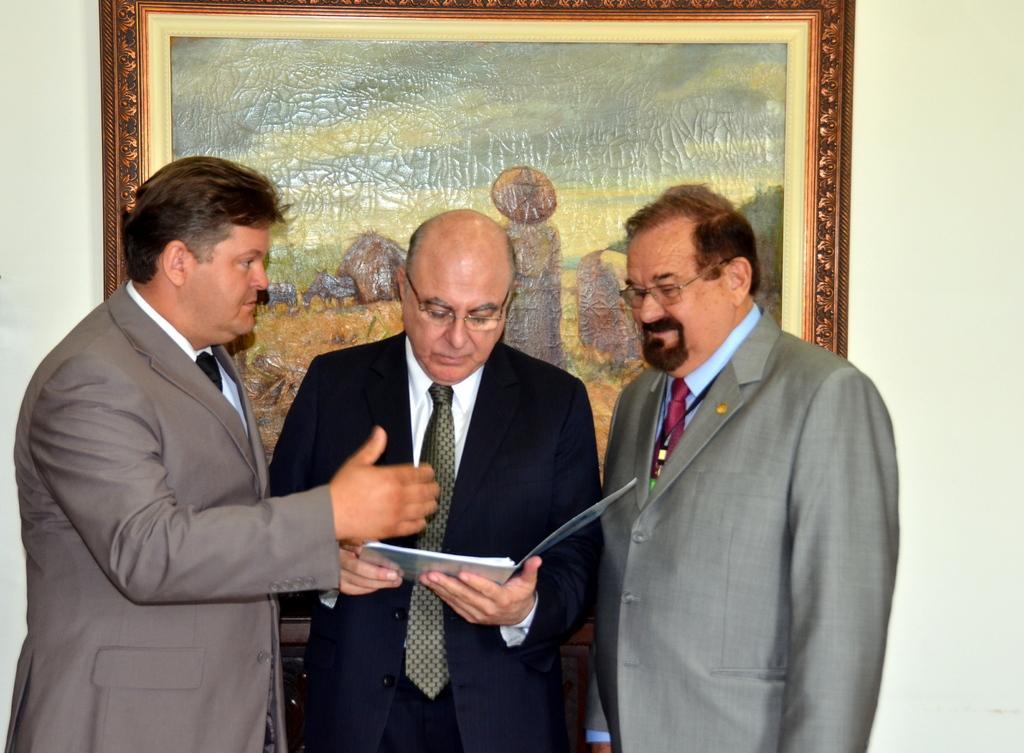Could you give a brief overview of what you see in this image? In this image I can see a person wearing white shirt, tie and black blazer is standing and holding a book in his hand and two other persons standing beside him. In the background I can see the wall and a photo frame attached to the wall. 